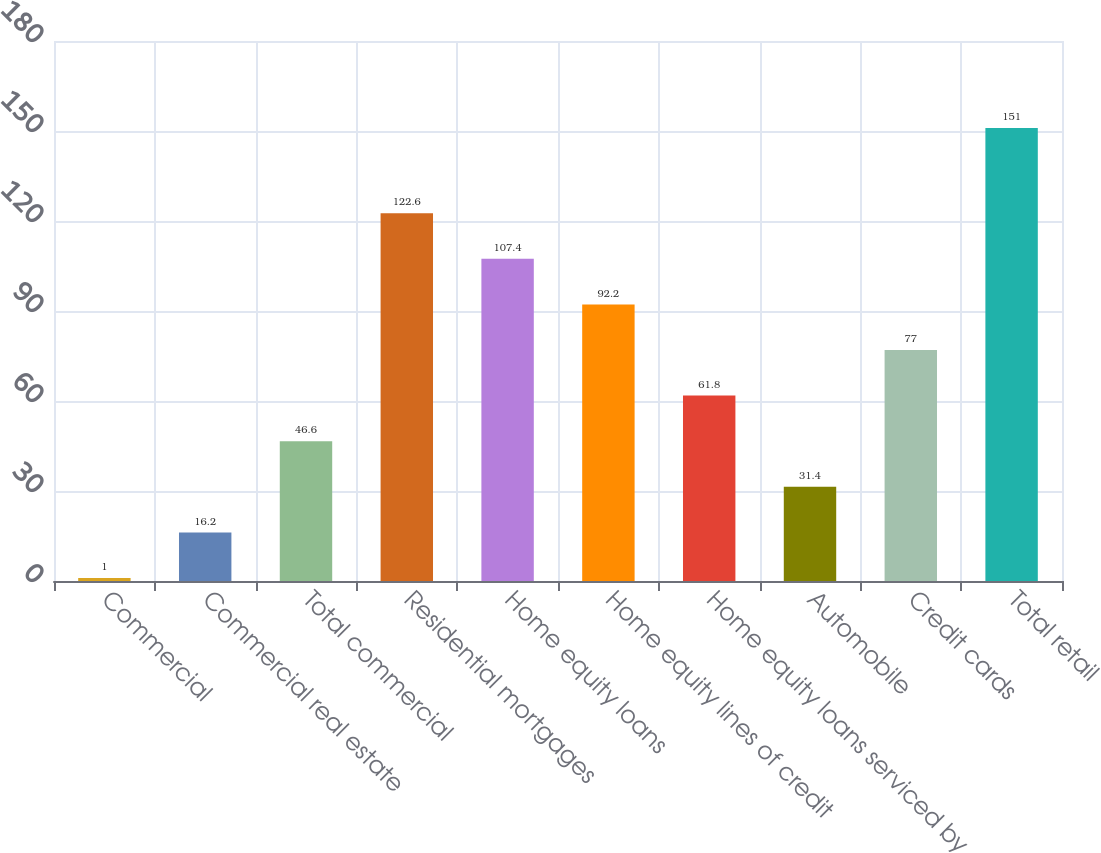Convert chart to OTSL. <chart><loc_0><loc_0><loc_500><loc_500><bar_chart><fcel>Commercial<fcel>Commercial real estate<fcel>Total commercial<fcel>Residential mortgages<fcel>Home equity loans<fcel>Home equity lines of credit<fcel>Home equity loans serviced by<fcel>Automobile<fcel>Credit cards<fcel>Total retail<nl><fcel>1<fcel>16.2<fcel>46.6<fcel>122.6<fcel>107.4<fcel>92.2<fcel>61.8<fcel>31.4<fcel>77<fcel>151<nl></chart> 